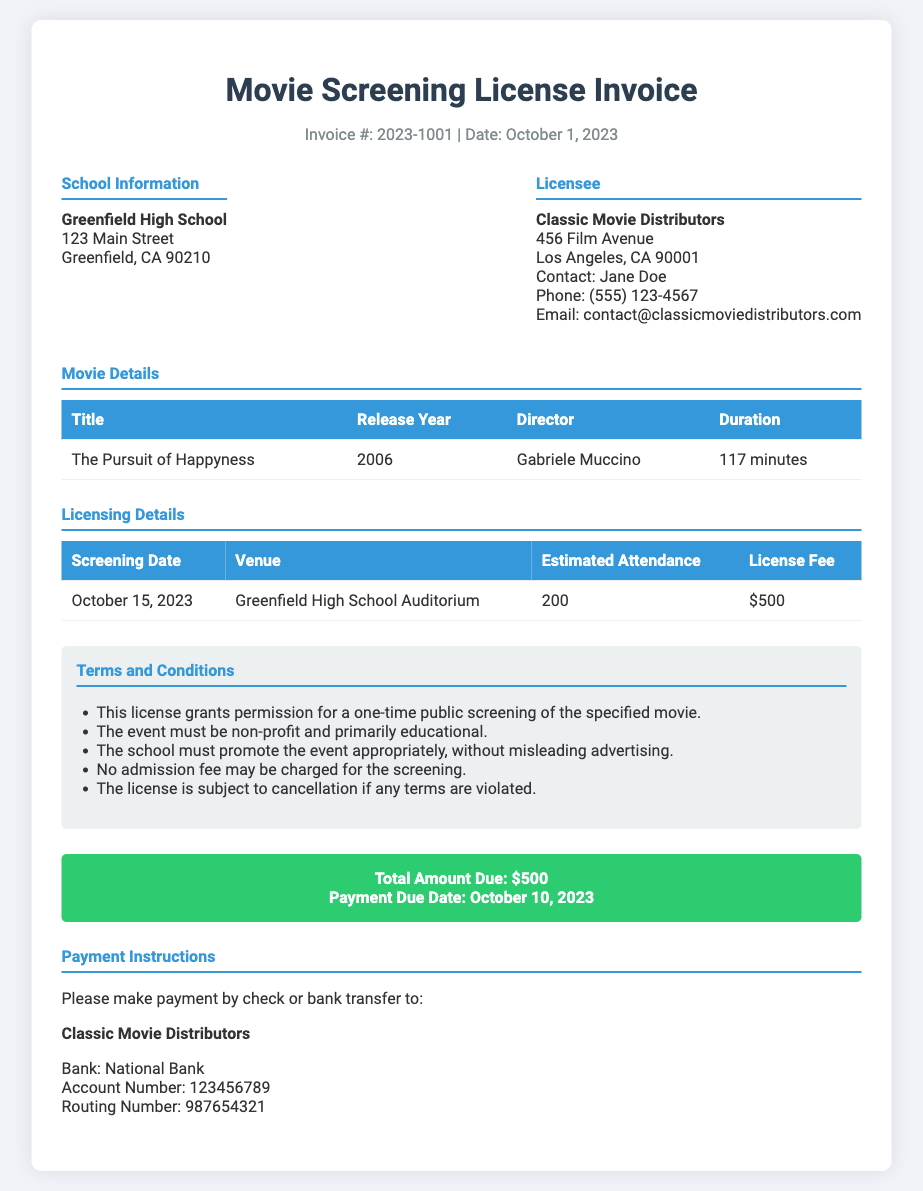What is the invoice number? The invoice number is mentioned at the top of the document.
Answer: 2023-1001 Who is the school listed in the document? The school name is provided in the School Information section.
Answer: Greenfield High School What is the total amount due? The total amount due is stated in the payment section of the document.
Answer: $500 What is the contact phone number for Classic Movie Distributors? The contact phone number is provided in the Licensee section.
Answer: (555) 123-4567 What is the release year of the movie? The release year is listed in the Movie Details table.
Answer: 2006 What is the estimated attendance for the screening? The estimated attendance is mentioned in the Licensing Details table.
Answer: 200 What is the screening date? The screening date is included in the Licensing Details table.
Answer: October 15, 2023 What is one condition of the licensing agreement? The conditions are listed in the Terms and Conditions section.
Answer: This license grants permission for a one-time public screening of the specified movie What payment methods are accepted? The document provides information on payment in the Payment Instructions section.
Answer: Check or bank transfer 